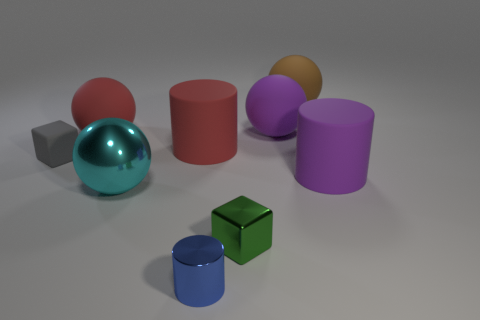Is the number of tiny shiny blocks that are left of the small gray cube the same as the number of brown rubber spheres on the left side of the big cyan metal ball?
Your answer should be compact. Yes. Do the big thing that is in front of the big purple rubber cylinder and the small green object have the same shape?
Provide a short and direct response. No. What number of green objects are either large matte objects or small cylinders?
Your answer should be compact. 0. What is the material of the large red thing that is the same shape as the blue metal object?
Keep it short and to the point. Rubber. What is the shape of the big purple thing behind the small gray cube?
Ensure brevity in your answer.  Sphere. Is there a big purple sphere made of the same material as the tiny gray cube?
Make the answer very short. Yes. Do the red rubber cylinder and the gray matte block have the same size?
Offer a terse response. No. How many cylinders are either small gray things or cyan shiny objects?
Offer a very short reply. 0. How many metallic things have the same shape as the tiny matte object?
Offer a very short reply. 1. Is the number of red matte cylinders on the left side of the red ball greater than the number of brown matte spheres left of the blue thing?
Ensure brevity in your answer.  No. 